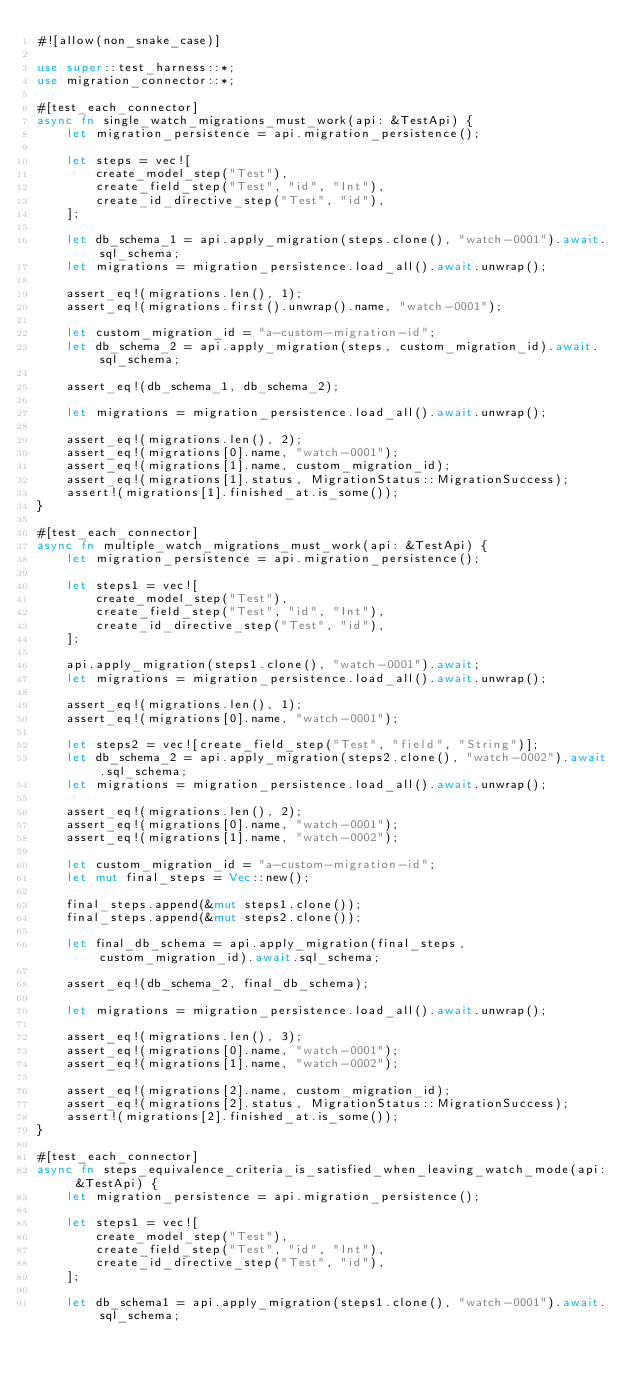Convert code to text. <code><loc_0><loc_0><loc_500><loc_500><_Rust_>#![allow(non_snake_case)]

use super::test_harness::*;
use migration_connector::*;

#[test_each_connector]
async fn single_watch_migrations_must_work(api: &TestApi) {
    let migration_persistence = api.migration_persistence();

    let steps = vec![
        create_model_step("Test"),
        create_field_step("Test", "id", "Int"),
        create_id_directive_step("Test", "id"),
    ];

    let db_schema_1 = api.apply_migration(steps.clone(), "watch-0001").await.sql_schema;
    let migrations = migration_persistence.load_all().await.unwrap();

    assert_eq!(migrations.len(), 1);
    assert_eq!(migrations.first().unwrap().name, "watch-0001");

    let custom_migration_id = "a-custom-migration-id";
    let db_schema_2 = api.apply_migration(steps, custom_migration_id).await.sql_schema;

    assert_eq!(db_schema_1, db_schema_2);

    let migrations = migration_persistence.load_all().await.unwrap();

    assert_eq!(migrations.len(), 2);
    assert_eq!(migrations[0].name, "watch-0001");
    assert_eq!(migrations[1].name, custom_migration_id);
    assert_eq!(migrations[1].status, MigrationStatus::MigrationSuccess);
    assert!(migrations[1].finished_at.is_some());
}

#[test_each_connector]
async fn multiple_watch_migrations_must_work(api: &TestApi) {
    let migration_persistence = api.migration_persistence();

    let steps1 = vec![
        create_model_step("Test"),
        create_field_step("Test", "id", "Int"),
        create_id_directive_step("Test", "id"),
    ];

    api.apply_migration(steps1.clone(), "watch-0001").await;
    let migrations = migration_persistence.load_all().await.unwrap();

    assert_eq!(migrations.len(), 1);
    assert_eq!(migrations[0].name, "watch-0001");

    let steps2 = vec![create_field_step("Test", "field", "String")];
    let db_schema_2 = api.apply_migration(steps2.clone(), "watch-0002").await.sql_schema;
    let migrations = migration_persistence.load_all().await.unwrap();

    assert_eq!(migrations.len(), 2);
    assert_eq!(migrations[0].name, "watch-0001");
    assert_eq!(migrations[1].name, "watch-0002");

    let custom_migration_id = "a-custom-migration-id";
    let mut final_steps = Vec::new();

    final_steps.append(&mut steps1.clone());
    final_steps.append(&mut steps2.clone());

    let final_db_schema = api.apply_migration(final_steps, custom_migration_id).await.sql_schema;

    assert_eq!(db_schema_2, final_db_schema);

    let migrations = migration_persistence.load_all().await.unwrap();

    assert_eq!(migrations.len(), 3);
    assert_eq!(migrations[0].name, "watch-0001");
    assert_eq!(migrations[1].name, "watch-0002");

    assert_eq!(migrations[2].name, custom_migration_id);
    assert_eq!(migrations[2].status, MigrationStatus::MigrationSuccess);
    assert!(migrations[2].finished_at.is_some());
}

#[test_each_connector]
async fn steps_equivalence_criteria_is_satisfied_when_leaving_watch_mode(api: &TestApi) {
    let migration_persistence = api.migration_persistence();

    let steps1 = vec![
        create_model_step("Test"),
        create_field_step("Test", "id", "Int"),
        create_id_directive_step("Test", "id"),
    ];

    let db_schema1 = api.apply_migration(steps1.clone(), "watch-0001").await.sql_schema;
</code> 